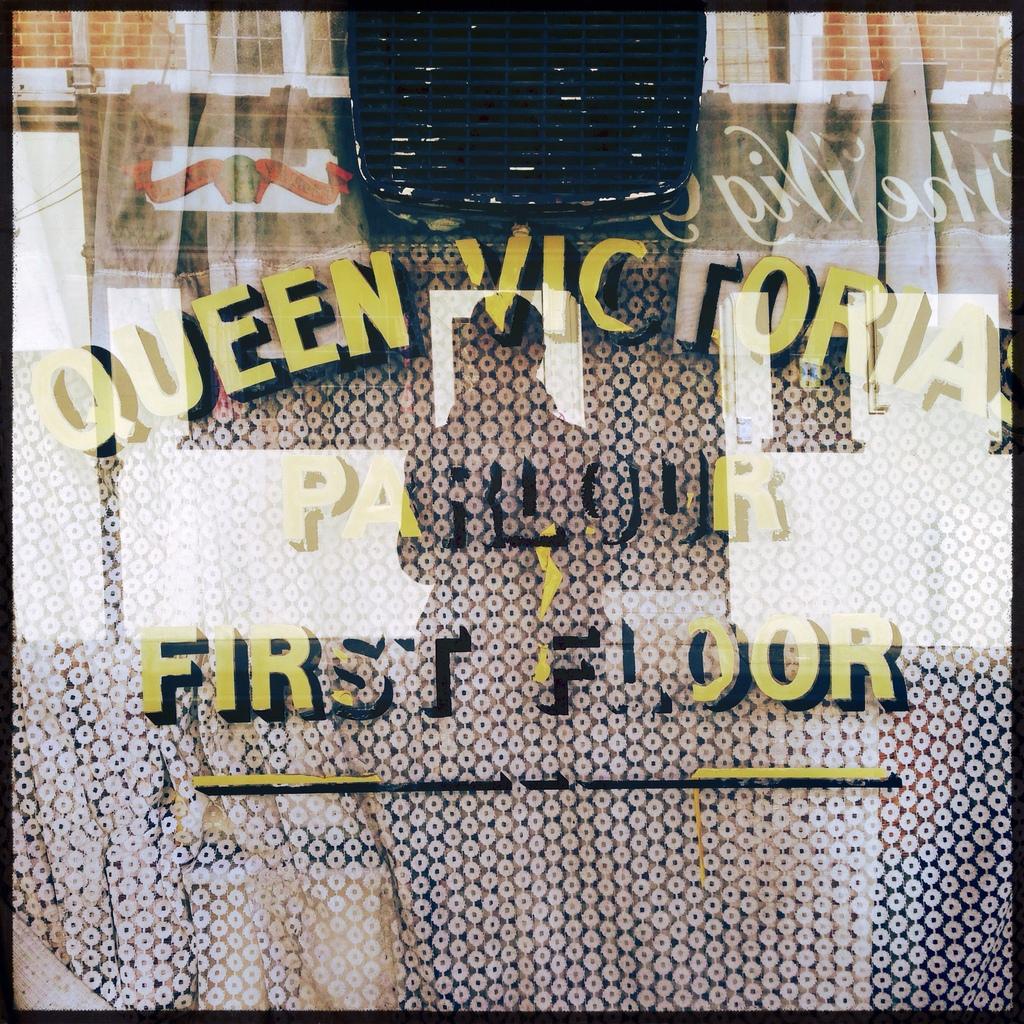What kind of royalty is victoria?
Offer a very short reply. Queen. What floor on they on?
Offer a terse response. First. 